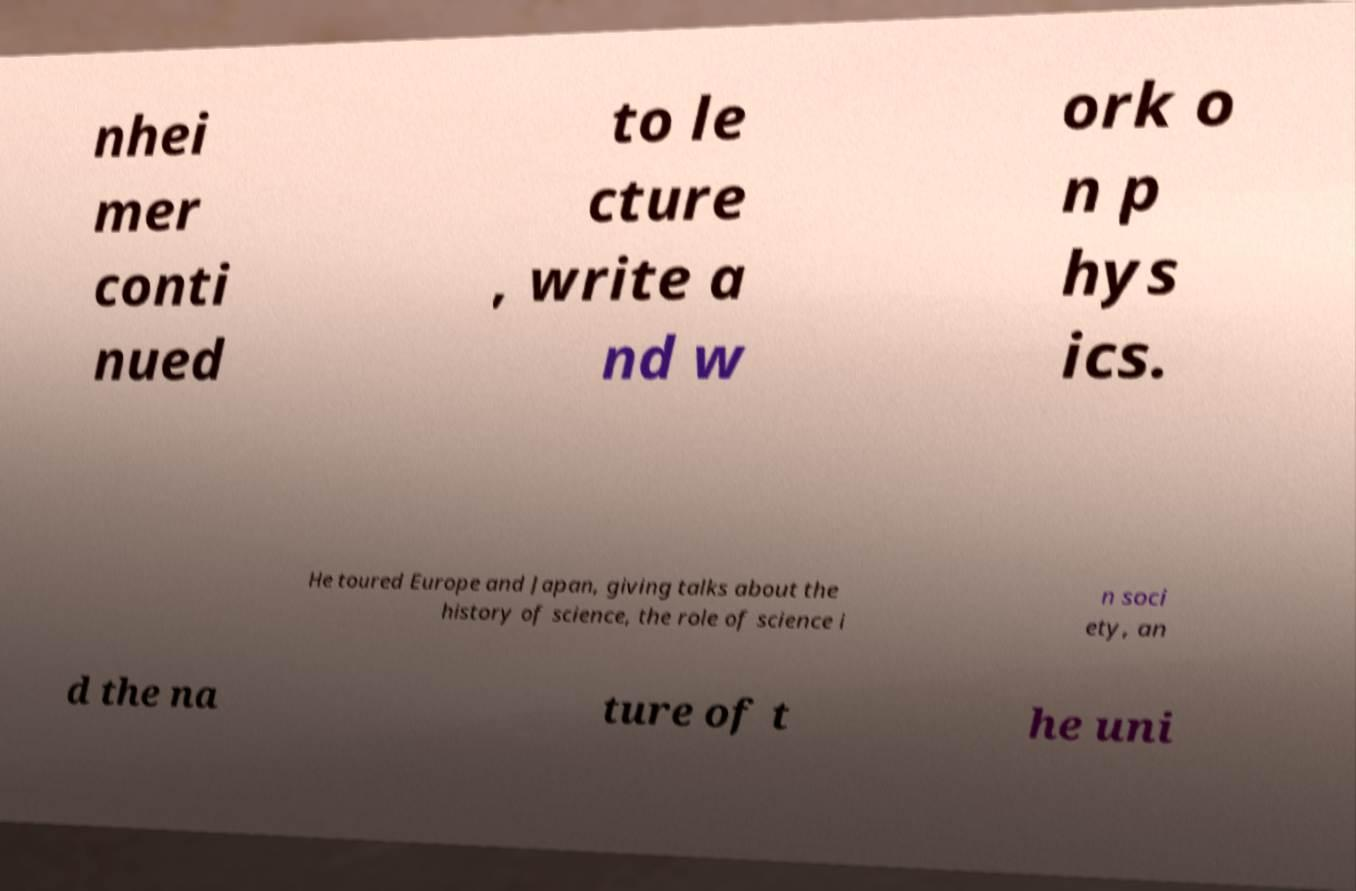Can you accurately transcribe the text from the provided image for me? nhei mer conti nued to le cture , write a nd w ork o n p hys ics. He toured Europe and Japan, giving talks about the history of science, the role of science i n soci ety, an d the na ture of t he uni 